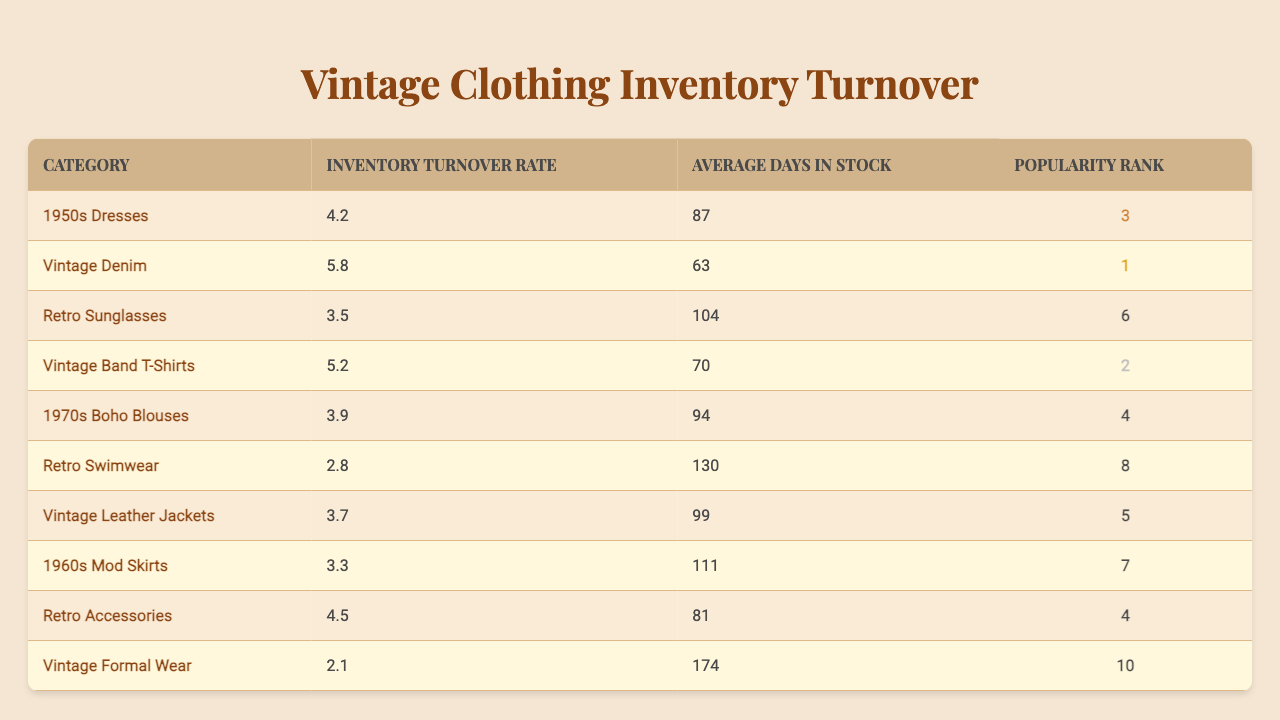What is the inventory turnover rate for Vintage Denim? The table shows that the inventory turnover rate for Vintage Denim is listed directly under that category. According to the table, it is 5.8.
Answer: 5.8 Which category has the highest inventory turnover rate? By comparing the inventory turnover rates in the table, Vintage Denim has the highest rate at 5.8.
Answer: Vintage Denim What is the average number of days in stock for 1970s Boho Blouses? The table specifically states the average number of days in stock for 1970s Boho Blouses, which is 94 days.
Answer: 94 days Is the inventory turnover rate for Vintage Leather Jackets higher than that for Retro Sunglasses? The inventory turnover rate for Vintage Leather Jackets is 3.7, while Retro Sunglasses has a rate of 3.5. Since 3.7 is greater than 3.5, the statement is true.
Answer: Yes What is the average inventory turnover rate for categories ranked 1 to 5? The inventory turnover rates for categories ranked 1 to 5 are 5.8 (Vintage Denim), 5.2 (Vintage Band T-Shirts), 4.2 (1950s Dresses), 3.7 (Vintage Leather Jackets), and 4.5 (Retro Accessories). Summing these gives 5.8 + 5.2 + 4.2 + 3.7 + 4.5 = 23.4. Dividing by 5 gives an average of 23.4 / 5 = 4.68.
Answer: 4.68 Which category has both high inventory turnover and low average days in stock? First, we look for categories with high turnover rates above 4.2 (the average for the table). We can then check their average days in stock. Vintage Denim has a turnover rate of 5.8 and 63 days in stock, fulfilling both criteria.
Answer: Vintage Denim Are the average days in stock for Retro Swimwear considered low compared to the overall data? Examining the table, Retro Swimwear has 130 days in stock, which is higher than the average days for other categories. As no other category exceeds this, it's relatively high compared to others.
Answer: No What is the rank of the category with the lowest inventory turnover rate? The category with the lowest inventory turnover rate listed in the table is Vintage Formal Wear with a rate of 2.1, which is ranked 10th.
Answer: 10 Calculate the difference in inventory turnover rate between the highest and lowest ranked categories. The highest rank is for Vintage Denim at 5.8, and the lowest is Vintage Formal Wear at 2.1. The difference between them is 5.8 - 2.1 = 3.7.
Answer: 3.7 How does the average days in stock for Retro Accessories compare to that for Vintage Band T-Shirts? Retro Accessories has 81 days in stock, while Vintage Band T-Shirts has 70 days. Since 81 is greater than 70, Retro Accessories has more days in stock.
Answer: More Is the inventory turnover rate for 1960s Mod Skirts below the overall average for all categories? The overall average turnover rate can be calculated by taking the sum of all listed rates (4.2 + 5.8 + 3.5 + 5.2 + 3.9 + 2.8 + 3.7 + 3.3 + 4.5 + 2.1 = 34.0) and dividing by 10 (34.0 / 10 = 3.4). The rate for 1960s Mod Skirts is 3.3, which is below 3.4.
Answer: Yes 